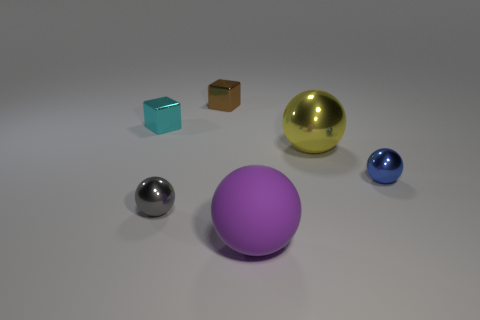Subtract 1 spheres. How many spheres are left? 3 Add 4 brown objects. How many objects exist? 10 Subtract all balls. How many objects are left? 2 Add 3 small metal balls. How many small metal balls exist? 5 Subtract 0 purple blocks. How many objects are left? 6 Subtract all rubber balls. Subtract all big purple metallic blocks. How many objects are left? 5 Add 2 purple spheres. How many purple spheres are left? 3 